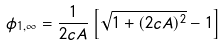Convert formula to latex. <formula><loc_0><loc_0><loc_500><loc_500>\phi _ { 1 , \infty } = \frac { 1 } { 2 c A } \left [ \sqrt { 1 + ( 2 c A ) ^ { 2 } } - 1 \right ]</formula> 